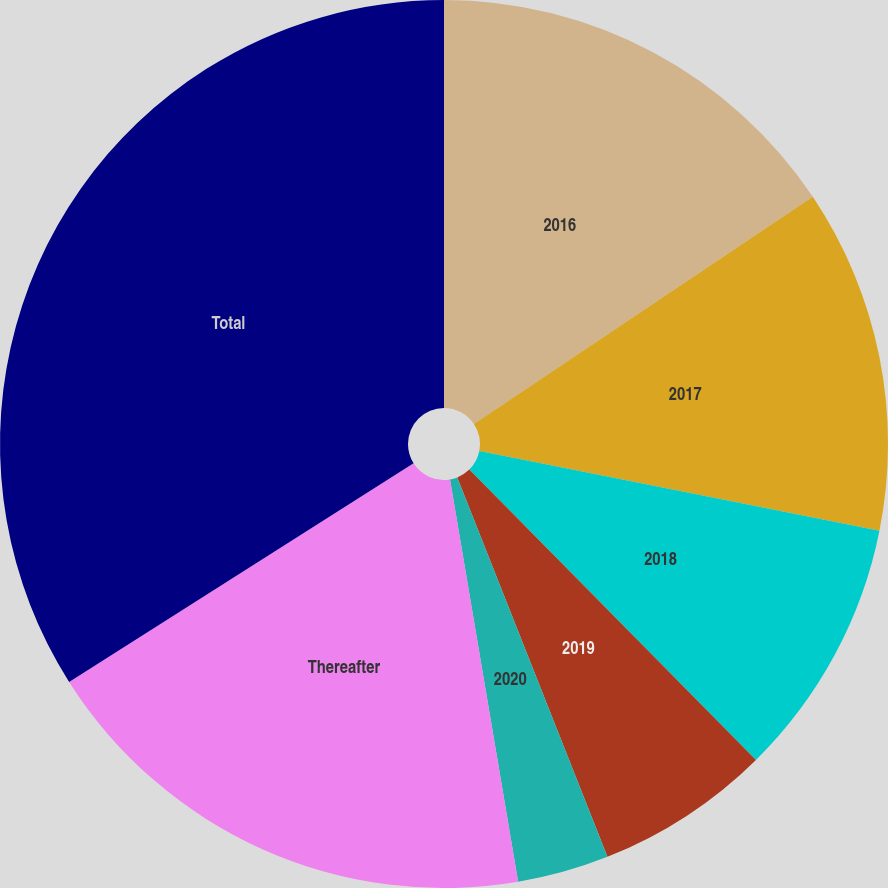Convert chart to OTSL. <chart><loc_0><loc_0><loc_500><loc_500><pie_chart><fcel>2016<fcel>2017<fcel>2018<fcel>2019<fcel>2020<fcel>Thereafter<fcel>Total<nl><fcel>15.6%<fcel>12.53%<fcel>9.47%<fcel>6.4%<fcel>3.33%<fcel>18.67%<fcel>34.0%<nl></chart> 